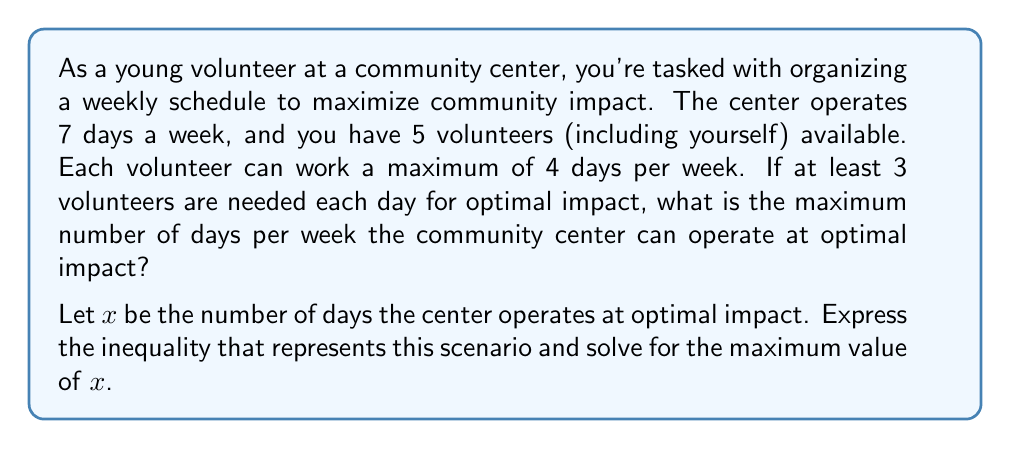Can you solve this math problem? Let's approach this step-by-step:

1) First, we need to set up our inequality:
   
   $3x \leq 5 \cdot 4$

   This is because:
   - We need at least 3 volunteers each day for optimal impact ($3x$)
   - We have 5 volunteers who can each work up to 4 days (5 · 4)

2) Simplify the right side of the inequality:
   
   $3x \leq 20$

3) Solve for $x$ by dividing both sides by 3:
   
   $x \leq \frac{20}{3}$

4) Since $x$ represents the number of days and must be a whole number, we need to round down to the nearest integer:

   $x \leq 6.67$, so the maximum value of $x$ is 6.

Therefore, the community center can operate at optimal impact for a maximum of 6 days per week.
Answer: 6 days 